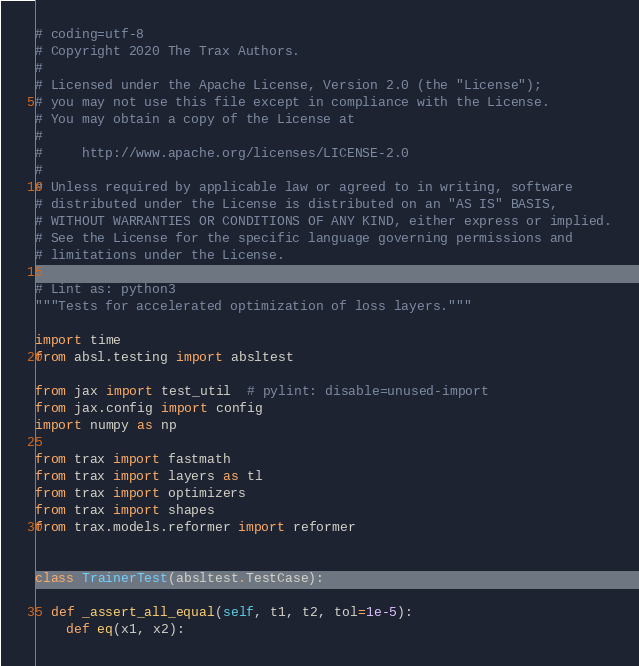Convert code to text. <code><loc_0><loc_0><loc_500><loc_500><_Python_># coding=utf-8
# Copyright 2020 The Trax Authors.
#
# Licensed under the Apache License, Version 2.0 (the "License");
# you may not use this file except in compliance with the License.
# You may obtain a copy of the License at
#
#     http://www.apache.org/licenses/LICENSE-2.0
#
# Unless required by applicable law or agreed to in writing, software
# distributed under the License is distributed on an "AS IS" BASIS,
# WITHOUT WARRANTIES OR CONDITIONS OF ANY KIND, either express or implied.
# See the License for the specific language governing permissions and
# limitations under the License.

# Lint as: python3
"""Tests for accelerated optimization of loss layers."""

import time
from absl.testing import absltest

from jax import test_util  # pylint: disable=unused-import
from jax.config import config
import numpy as np

from trax import fastmath
from trax import layers as tl
from trax import optimizers
from trax import shapes
from trax.models.reformer import reformer


class TrainerTest(absltest.TestCase):

  def _assert_all_equal(self, t1, t2, tol=1e-5):
    def eq(x1, x2):</code> 